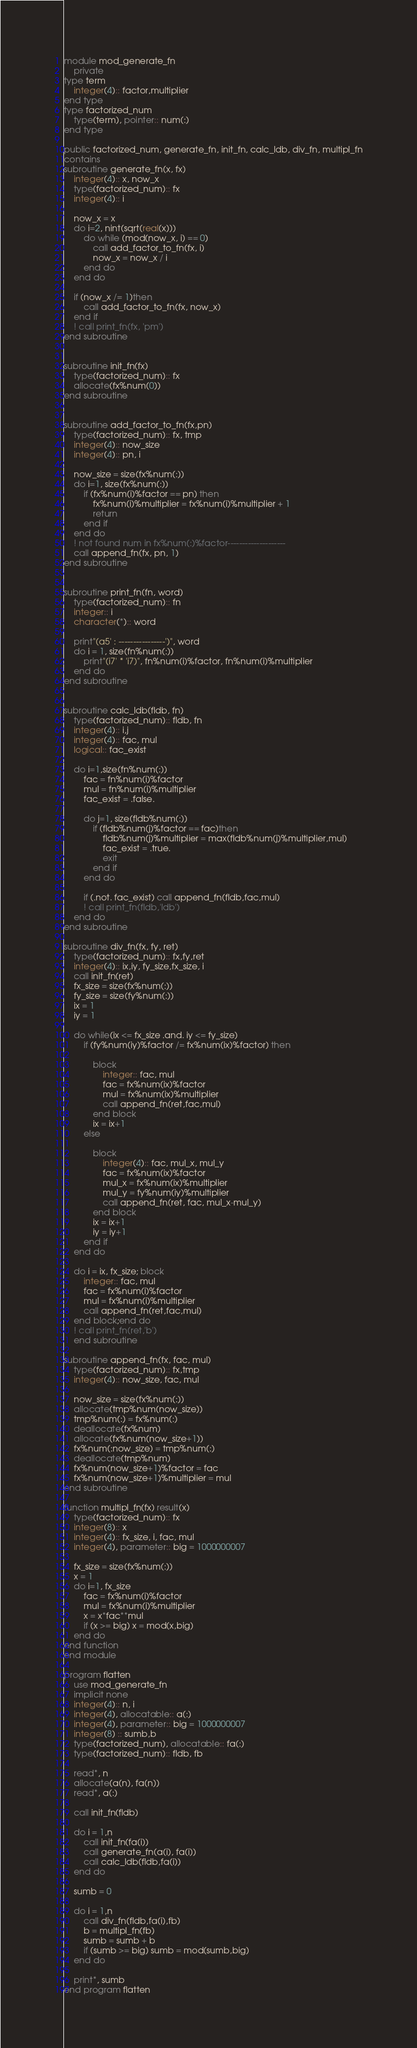<code> <loc_0><loc_0><loc_500><loc_500><_FORTRAN_>module mod_generate_fn
    private
type term
    integer(4):: factor,multiplier
end type
type factorized_num
    type(term), pointer:: num(:)
end type

public factorized_num, generate_fn, init_fn, calc_ldb, div_fn, multipl_fn
contains
subroutine generate_fn(x, fx)
    integer(4):: x, now_x
    type(factorized_num):: fx
    integer(4):: i

    now_x = x
    do i=2, nint(sqrt(real(x)))
        do while (mod(now_x, i) == 0)
            call add_factor_to_fn(fx, i)
            now_x = now_x / i
        end do
    end do

    if (now_x /= 1)then
        call add_factor_to_fn(fx, now_x)
    end if
    ! call print_fn(fx, 'pm')
end subroutine


subroutine init_fn(fx)
    type(factorized_num):: fx
    allocate(fx%num(0))
end subroutine


subroutine add_factor_to_fn(fx,pn)
    type(factorized_num):: fx, tmp
    integer(4):: now_size
    integer(4):: pn, i

    now_size = size(fx%num(:))
    do i=1, size(fx%num(:))
        if (fx%num(i)%factor == pn) then
            fx%num(i)%multiplier = fx%num(i)%multiplier + 1
            return
        end if
    end do
    ! not found num in fx%num(:)%factor--------------------
    call append_fn(fx, pn, 1)
end subroutine


subroutine print_fn(fn, word)
    type(factorized_num):: fn
    integer:: i
    character(*):: word

    print"(a5' : ----------------')", word
    do i = 1, size(fn%num(:))
        print"(i7' * 'i7)", fn%num(i)%factor, fn%num(i)%multiplier
    end do
end subroutine


subroutine calc_ldb(fldb, fn)
    type(factorized_num):: fldb, fn
    integer(4):: i,j
    integer(4):: fac, mul
    logical:: fac_exist
    
    do i=1,size(fn%num(:))
        fac = fn%num(i)%factor
        mul = fn%num(i)%multiplier
        fac_exist = .false.
        
        do j=1, size(fldb%num(:))
            if (fldb%num(j)%factor == fac)then
                fldb%num(j)%multiplier = max(fldb%num(j)%multiplier,mul)
                fac_exist = .true.
                exit
            end if
        end do

        if (.not. fac_exist) call append_fn(fldb,fac,mul)
        ! call print_fn(fldb,'ldb')
    end do
end subroutine

subroutine div_fn(fx, fy, ret)
    type(factorized_num):: fx,fy,ret
    integer(4):: ix,iy, fy_size,fx_size, i
    call init_fn(ret)
    fx_size = size(fx%num(:))
    fy_size = size(fy%num(:))
    ix = 1
    iy = 1

    do while(ix <= fx_size .and. iy <= fy_size)
        if (fy%num(iy)%factor /= fx%num(ix)%factor) then
            
            block
                integer:: fac, mul
                fac = fx%num(ix)%factor
                mul = fx%num(ix)%multiplier
                call append_fn(ret,fac,mul)
            end block
            ix = ix+1
        else

            block
                integer(4):: fac, mul_x, mul_y
                fac = fx%num(ix)%factor
                mul_x = fx%num(ix)%multiplier
                mul_y = fy%num(iy)%multiplier
                call append_fn(ret, fac, mul_x-mul_y)
            end block
            ix = ix+1
            iy = iy+1
        end if
    end do
    
    do i = ix, fx_size; block
        integer:: fac, mul
        fac = fx%num(i)%factor
        mul = fx%num(i)%multiplier
        call append_fn(ret,fac,mul)
    end block;end do
    ! call print_fn(ret,'b')
    end subroutine

subroutine append_fn(fx, fac, mul)
    type(factorized_num):: fx,tmp
    integer(4):: now_size, fac, mul

    now_size = size(fx%num(:))
    allocate(tmp%num(now_size))
    tmp%num(:) = fx%num(:)
    deallocate(fx%num)
    allocate(fx%num(now_size+1))
    fx%num(:now_size) = tmp%num(:)
    deallocate(tmp%num)
    fx%num(now_size+1)%factor = fac
    fx%num(now_size+1)%multiplier = mul
end subroutine

function multipl_fn(fx) result(x)
    type(factorized_num):: fx
    integer(8):: x
    integer(4):: fx_size, i, fac, mul
    integer(4), parameter:: big = 1000000007

    fx_size = size(fx%num(:))
    x = 1
    do i=1, fx_size
        fac = fx%num(i)%factor
        mul = fx%num(i)%multiplier
        x = x*fac**mul
        if (x >= big) x = mod(x,big)
    end do
end function
end module

program flatten
    use mod_generate_fn
    implicit none
    integer(4):: n, i
    integer(4), allocatable:: a(:)
    integer(4), parameter:: big = 1000000007
    integer(8) :: sumb,b
    type(factorized_num), allocatable:: fa(:)
    type(factorized_num):: fldb, fb

    read*, n
    allocate(a(n), fa(n))
    read*, a(:)

    call init_fn(fldb)
    
    do i = 1,n
        call init_fn(fa(i))
        call generate_fn(a(i), fa(i))
        call calc_ldb(fldb,fa(i))
    end do

    sumb = 0

    do i = 1,n
        call div_fn(fldb,fa(i),fb)
        b = multipl_fn(fb)
        sumb = sumb + b
        if (sumb >= big) sumb = mod(sumb,big)
    end do

    print*, sumb
end program flatten</code> 